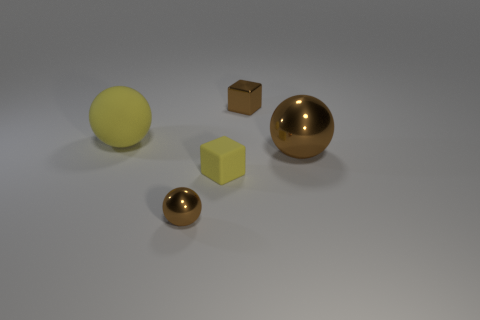Subtract all brown balls. How many balls are left? 1 Add 3 small yellow rubber cubes. How many objects exist? 8 Subtract all blocks. How many objects are left? 3 Add 3 large things. How many large things are left? 5 Add 5 tiny yellow cubes. How many tiny yellow cubes exist? 6 Subtract 0 gray blocks. How many objects are left? 5 Subtract all big green shiny spheres. Subtract all tiny yellow things. How many objects are left? 4 